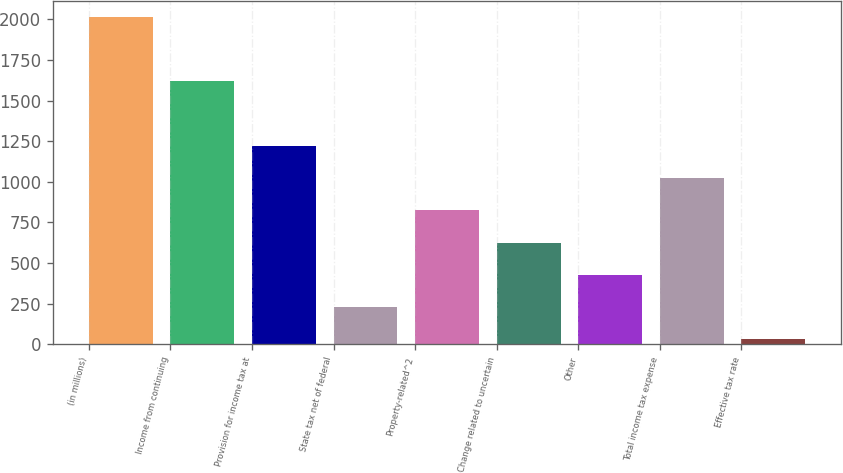Convert chart. <chart><loc_0><loc_0><loc_500><loc_500><bar_chart><fcel>(in millions)<fcel>Income from continuing<fcel>Provision for income tax at<fcel>State tax net of federal<fcel>Property-related^2<fcel>Change related to uncertain<fcel>Other<fcel>Total income tax expense<fcel>Effective tax rate<nl><fcel>2015<fcel>1618<fcel>1221.52<fcel>229.67<fcel>824.78<fcel>626.41<fcel>428.04<fcel>1023.15<fcel>31.3<nl></chart> 